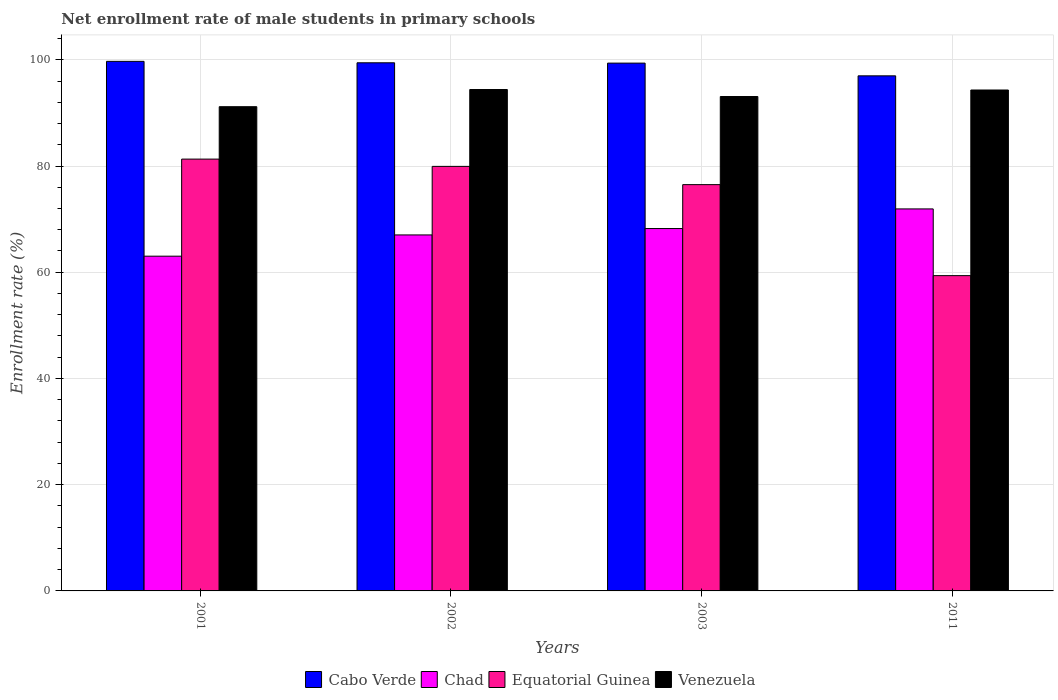How many groups of bars are there?
Give a very brief answer. 4. Are the number of bars per tick equal to the number of legend labels?
Keep it short and to the point. Yes. Are the number of bars on each tick of the X-axis equal?
Provide a succinct answer. Yes. What is the label of the 2nd group of bars from the left?
Your response must be concise. 2002. What is the net enrollment rate of male students in primary schools in Cabo Verde in 2011?
Make the answer very short. 96.98. Across all years, what is the maximum net enrollment rate of male students in primary schools in Chad?
Provide a succinct answer. 71.92. Across all years, what is the minimum net enrollment rate of male students in primary schools in Chad?
Provide a short and direct response. 63.02. In which year was the net enrollment rate of male students in primary schools in Cabo Verde maximum?
Keep it short and to the point. 2001. What is the total net enrollment rate of male students in primary schools in Cabo Verde in the graph?
Provide a succinct answer. 395.49. What is the difference between the net enrollment rate of male students in primary schools in Venezuela in 2003 and that in 2011?
Ensure brevity in your answer.  -1.23. What is the difference between the net enrollment rate of male students in primary schools in Cabo Verde in 2001 and the net enrollment rate of male students in primary schools in Chad in 2002?
Your response must be concise. 32.68. What is the average net enrollment rate of male students in primary schools in Chad per year?
Provide a succinct answer. 67.55. In the year 2003, what is the difference between the net enrollment rate of male students in primary schools in Equatorial Guinea and net enrollment rate of male students in primary schools in Chad?
Keep it short and to the point. 8.27. What is the ratio of the net enrollment rate of male students in primary schools in Chad in 2001 to that in 2003?
Offer a terse response. 0.92. Is the difference between the net enrollment rate of male students in primary schools in Equatorial Guinea in 2002 and 2011 greater than the difference between the net enrollment rate of male students in primary schools in Chad in 2002 and 2011?
Provide a succinct answer. Yes. What is the difference between the highest and the second highest net enrollment rate of male students in primary schools in Equatorial Guinea?
Offer a very short reply. 1.37. What is the difference between the highest and the lowest net enrollment rate of male students in primary schools in Equatorial Guinea?
Make the answer very short. 21.94. Is it the case that in every year, the sum of the net enrollment rate of male students in primary schools in Cabo Verde and net enrollment rate of male students in primary schools in Equatorial Guinea is greater than the sum of net enrollment rate of male students in primary schools in Chad and net enrollment rate of male students in primary schools in Venezuela?
Keep it short and to the point. Yes. What does the 2nd bar from the left in 2002 represents?
Your response must be concise. Chad. What does the 2nd bar from the right in 2001 represents?
Provide a succinct answer. Equatorial Guinea. Is it the case that in every year, the sum of the net enrollment rate of male students in primary schools in Equatorial Guinea and net enrollment rate of male students in primary schools in Cabo Verde is greater than the net enrollment rate of male students in primary schools in Chad?
Give a very brief answer. Yes. Are all the bars in the graph horizontal?
Your answer should be very brief. No. How many years are there in the graph?
Your answer should be compact. 4. Does the graph contain any zero values?
Ensure brevity in your answer.  No. How are the legend labels stacked?
Provide a short and direct response. Horizontal. What is the title of the graph?
Provide a succinct answer. Net enrollment rate of male students in primary schools. What is the label or title of the X-axis?
Ensure brevity in your answer.  Years. What is the label or title of the Y-axis?
Your answer should be compact. Enrollment rate (%). What is the Enrollment rate (%) of Cabo Verde in 2001?
Your response must be concise. 99.71. What is the Enrollment rate (%) of Chad in 2001?
Offer a very short reply. 63.02. What is the Enrollment rate (%) of Equatorial Guinea in 2001?
Keep it short and to the point. 81.3. What is the Enrollment rate (%) in Venezuela in 2001?
Provide a short and direct response. 91.17. What is the Enrollment rate (%) of Cabo Verde in 2002?
Keep it short and to the point. 99.43. What is the Enrollment rate (%) in Chad in 2002?
Your answer should be very brief. 67.02. What is the Enrollment rate (%) of Equatorial Guinea in 2002?
Give a very brief answer. 79.93. What is the Enrollment rate (%) of Venezuela in 2002?
Provide a succinct answer. 94.4. What is the Enrollment rate (%) in Cabo Verde in 2003?
Ensure brevity in your answer.  99.38. What is the Enrollment rate (%) in Chad in 2003?
Your response must be concise. 68.23. What is the Enrollment rate (%) of Equatorial Guinea in 2003?
Make the answer very short. 76.5. What is the Enrollment rate (%) of Venezuela in 2003?
Make the answer very short. 93.08. What is the Enrollment rate (%) in Cabo Verde in 2011?
Provide a short and direct response. 96.98. What is the Enrollment rate (%) of Chad in 2011?
Offer a very short reply. 71.92. What is the Enrollment rate (%) of Equatorial Guinea in 2011?
Your answer should be compact. 59.36. What is the Enrollment rate (%) of Venezuela in 2011?
Your response must be concise. 94.31. Across all years, what is the maximum Enrollment rate (%) of Cabo Verde?
Your answer should be compact. 99.71. Across all years, what is the maximum Enrollment rate (%) of Chad?
Your answer should be compact. 71.92. Across all years, what is the maximum Enrollment rate (%) in Equatorial Guinea?
Offer a very short reply. 81.3. Across all years, what is the maximum Enrollment rate (%) of Venezuela?
Provide a succinct answer. 94.4. Across all years, what is the minimum Enrollment rate (%) of Cabo Verde?
Your response must be concise. 96.98. Across all years, what is the minimum Enrollment rate (%) of Chad?
Offer a very short reply. 63.02. Across all years, what is the minimum Enrollment rate (%) in Equatorial Guinea?
Make the answer very short. 59.36. Across all years, what is the minimum Enrollment rate (%) in Venezuela?
Provide a succinct answer. 91.17. What is the total Enrollment rate (%) of Cabo Verde in the graph?
Provide a succinct answer. 395.49. What is the total Enrollment rate (%) of Chad in the graph?
Your response must be concise. 270.2. What is the total Enrollment rate (%) of Equatorial Guinea in the graph?
Your response must be concise. 297.09. What is the total Enrollment rate (%) in Venezuela in the graph?
Your response must be concise. 372.97. What is the difference between the Enrollment rate (%) of Cabo Verde in 2001 and that in 2002?
Your answer should be very brief. 0.27. What is the difference between the Enrollment rate (%) in Chad in 2001 and that in 2002?
Offer a very short reply. -4. What is the difference between the Enrollment rate (%) in Equatorial Guinea in 2001 and that in 2002?
Provide a short and direct response. 1.37. What is the difference between the Enrollment rate (%) in Venezuela in 2001 and that in 2002?
Give a very brief answer. -3.23. What is the difference between the Enrollment rate (%) in Cabo Verde in 2001 and that in 2003?
Keep it short and to the point. 0.33. What is the difference between the Enrollment rate (%) in Chad in 2001 and that in 2003?
Keep it short and to the point. -5.21. What is the difference between the Enrollment rate (%) of Equatorial Guinea in 2001 and that in 2003?
Offer a terse response. 4.8. What is the difference between the Enrollment rate (%) of Venezuela in 2001 and that in 2003?
Offer a terse response. -1.91. What is the difference between the Enrollment rate (%) in Cabo Verde in 2001 and that in 2011?
Make the answer very short. 2.73. What is the difference between the Enrollment rate (%) in Chad in 2001 and that in 2011?
Ensure brevity in your answer.  -8.9. What is the difference between the Enrollment rate (%) of Equatorial Guinea in 2001 and that in 2011?
Your answer should be very brief. 21.94. What is the difference between the Enrollment rate (%) of Venezuela in 2001 and that in 2011?
Offer a terse response. -3.14. What is the difference between the Enrollment rate (%) of Cabo Verde in 2002 and that in 2003?
Provide a short and direct response. 0.06. What is the difference between the Enrollment rate (%) in Chad in 2002 and that in 2003?
Your answer should be very brief. -1.2. What is the difference between the Enrollment rate (%) of Equatorial Guinea in 2002 and that in 2003?
Provide a succinct answer. 3.44. What is the difference between the Enrollment rate (%) in Venezuela in 2002 and that in 2003?
Ensure brevity in your answer.  1.32. What is the difference between the Enrollment rate (%) in Cabo Verde in 2002 and that in 2011?
Make the answer very short. 2.46. What is the difference between the Enrollment rate (%) of Chad in 2002 and that in 2011?
Provide a short and direct response. -4.9. What is the difference between the Enrollment rate (%) of Equatorial Guinea in 2002 and that in 2011?
Your answer should be compact. 20.57. What is the difference between the Enrollment rate (%) in Venezuela in 2002 and that in 2011?
Give a very brief answer. 0.09. What is the difference between the Enrollment rate (%) in Cabo Verde in 2003 and that in 2011?
Provide a short and direct response. 2.4. What is the difference between the Enrollment rate (%) in Chad in 2003 and that in 2011?
Give a very brief answer. -3.69. What is the difference between the Enrollment rate (%) of Equatorial Guinea in 2003 and that in 2011?
Keep it short and to the point. 17.14. What is the difference between the Enrollment rate (%) of Venezuela in 2003 and that in 2011?
Keep it short and to the point. -1.23. What is the difference between the Enrollment rate (%) of Cabo Verde in 2001 and the Enrollment rate (%) of Chad in 2002?
Your answer should be compact. 32.68. What is the difference between the Enrollment rate (%) in Cabo Verde in 2001 and the Enrollment rate (%) in Equatorial Guinea in 2002?
Your answer should be very brief. 19.77. What is the difference between the Enrollment rate (%) of Cabo Verde in 2001 and the Enrollment rate (%) of Venezuela in 2002?
Offer a terse response. 5.31. What is the difference between the Enrollment rate (%) of Chad in 2001 and the Enrollment rate (%) of Equatorial Guinea in 2002?
Ensure brevity in your answer.  -16.91. What is the difference between the Enrollment rate (%) in Chad in 2001 and the Enrollment rate (%) in Venezuela in 2002?
Provide a short and direct response. -31.38. What is the difference between the Enrollment rate (%) in Equatorial Guinea in 2001 and the Enrollment rate (%) in Venezuela in 2002?
Provide a short and direct response. -13.1. What is the difference between the Enrollment rate (%) in Cabo Verde in 2001 and the Enrollment rate (%) in Chad in 2003?
Make the answer very short. 31.48. What is the difference between the Enrollment rate (%) of Cabo Verde in 2001 and the Enrollment rate (%) of Equatorial Guinea in 2003?
Ensure brevity in your answer.  23.21. What is the difference between the Enrollment rate (%) in Cabo Verde in 2001 and the Enrollment rate (%) in Venezuela in 2003?
Your answer should be very brief. 6.62. What is the difference between the Enrollment rate (%) in Chad in 2001 and the Enrollment rate (%) in Equatorial Guinea in 2003?
Your response must be concise. -13.47. What is the difference between the Enrollment rate (%) of Chad in 2001 and the Enrollment rate (%) of Venezuela in 2003?
Ensure brevity in your answer.  -30.06. What is the difference between the Enrollment rate (%) of Equatorial Guinea in 2001 and the Enrollment rate (%) of Venezuela in 2003?
Your answer should be very brief. -11.78. What is the difference between the Enrollment rate (%) of Cabo Verde in 2001 and the Enrollment rate (%) of Chad in 2011?
Offer a very short reply. 27.78. What is the difference between the Enrollment rate (%) of Cabo Verde in 2001 and the Enrollment rate (%) of Equatorial Guinea in 2011?
Provide a succinct answer. 40.35. What is the difference between the Enrollment rate (%) in Cabo Verde in 2001 and the Enrollment rate (%) in Venezuela in 2011?
Ensure brevity in your answer.  5.39. What is the difference between the Enrollment rate (%) in Chad in 2001 and the Enrollment rate (%) in Equatorial Guinea in 2011?
Provide a succinct answer. 3.66. What is the difference between the Enrollment rate (%) of Chad in 2001 and the Enrollment rate (%) of Venezuela in 2011?
Provide a succinct answer. -31.29. What is the difference between the Enrollment rate (%) in Equatorial Guinea in 2001 and the Enrollment rate (%) in Venezuela in 2011?
Your answer should be compact. -13.01. What is the difference between the Enrollment rate (%) of Cabo Verde in 2002 and the Enrollment rate (%) of Chad in 2003?
Your response must be concise. 31.21. What is the difference between the Enrollment rate (%) of Cabo Verde in 2002 and the Enrollment rate (%) of Equatorial Guinea in 2003?
Ensure brevity in your answer.  22.94. What is the difference between the Enrollment rate (%) in Cabo Verde in 2002 and the Enrollment rate (%) in Venezuela in 2003?
Keep it short and to the point. 6.35. What is the difference between the Enrollment rate (%) of Chad in 2002 and the Enrollment rate (%) of Equatorial Guinea in 2003?
Your answer should be very brief. -9.47. What is the difference between the Enrollment rate (%) in Chad in 2002 and the Enrollment rate (%) in Venezuela in 2003?
Your answer should be very brief. -26.06. What is the difference between the Enrollment rate (%) of Equatorial Guinea in 2002 and the Enrollment rate (%) of Venezuela in 2003?
Offer a terse response. -13.15. What is the difference between the Enrollment rate (%) of Cabo Verde in 2002 and the Enrollment rate (%) of Chad in 2011?
Ensure brevity in your answer.  27.51. What is the difference between the Enrollment rate (%) of Cabo Verde in 2002 and the Enrollment rate (%) of Equatorial Guinea in 2011?
Your answer should be very brief. 40.07. What is the difference between the Enrollment rate (%) of Cabo Verde in 2002 and the Enrollment rate (%) of Venezuela in 2011?
Ensure brevity in your answer.  5.12. What is the difference between the Enrollment rate (%) of Chad in 2002 and the Enrollment rate (%) of Equatorial Guinea in 2011?
Your answer should be very brief. 7.66. What is the difference between the Enrollment rate (%) in Chad in 2002 and the Enrollment rate (%) in Venezuela in 2011?
Provide a succinct answer. -27.29. What is the difference between the Enrollment rate (%) of Equatorial Guinea in 2002 and the Enrollment rate (%) of Venezuela in 2011?
Make the answer very short. -14.38. What is the difference between the Enrollment rate (%) in Cabo Verde in 2003 and the Enrollment rate (%) in Chad in 2011?
Your answer should be compact. 27.45. What is the difference between the Enrollment rate (%) of Cabo Verde in 2003 and the Enrollment rate (%) of Equatorial Guinea in 2011?
Your answer should be compact. 40.01. What is the difference between the Enrollment rate (%) in Cabo Verde in 2003 and the Enrollment rate (%) in Venezuela in 2011?
Give a very brief answer. 5.06. What is the difference between the Enrollment rate (%) in Chad in 2003 and the Enrollment rate (%) in Equatorial Guinea in 2011?
Offer a terse response. 8.87. What is the difference between the Enrollment rate (%) of Chad in 2003 and the Enrollment rate (%) of Venezuela in 2011?
Ensure brevity in your answer.  -26.08. What is the difference between the Enrollment rate (%) in Equatorial Guinea in 2003 and the Enrollment rate (%) in Venezuela in 2011?
Keep it short and to the point. -17.82. What is the average Enrollment rate (%) of Cabo Verde per year?
Provide a succinct answer. 98.87. What is the average Enrollment rate (%) of Chad per year?
Keep it short and to the point. 67.55. What is the average Enrollment rate (%) of Equatorial Guinea per year?
Ensure brevity in your answer.  74.27. What is the average Enrollment rate (%) in Venezuela per year?
Offer a terse response. 93.24. In the year 2001, what is the difference between the Enrollment rate (%) in Cabo Verde and Enrollment rate (%) in Chad?
Your answer should be compact. 36.68. In the year 2001, what is the difference between the Enrollment rate (%) of Cabo Verde and Enrollment rate (%) of Equatorial Guinea?
Provide a short and direct response. 18.41. In the year 2001, what is the difference between the Enrollment rate (%) in Cabo Verde and Enrollment rate (%) in Venezuela?
Offer a very short reply. 8.54. In the year 2001, what is the difference between the Enrollment rate (%) of Chad and Enrollment rate (%) of Equatorial Guinea?
Your answer should be very brief. -18.28. In the year 2001, what is the difference between the Enrollment rate (%) in Chad and Enrollment rate (%) in Venezuela?
Your response must be concise. -28.14. In the year 2001, what is the difference between the Enrollment rate (%) in Equatorial Guinea and Enrollment rate (%) in Venezuela?
Provide a short and direct response. -9.87. In the year 2002, what is the difference between the Enrollment rate (%) in Cabo Verde and Enrollment rate (%) in Chad?
Your response must be concise. 32.41. In the year 2002, what is the difference between the Enrollment rate (%) of Cabo Verde and Enrollment rate (%) of Equatorial Guinea?
Provide a succinct answer. 19.5. In the year 2002, what is the difference between the Enrollment rate (%) of Cabo Verde and Enrollment rate (%) of Venezuela?
Offer a terse response. 5.03. In the year 2002, what is the difference between the Enrollment rate (%) in Chad and Enrollment rate (%) in Equatorial Guinea?
Offer a terse response. -12.91. In the year 2002, what is the difference between the Enrollment rate (%) of Chad and Enrollment rate (%) of Venezuela?
Ensure brevity in your answer.  -27.38. In the year 2002, what is the difference between the Enrollment rate (%) in Equatorial Guinea and Enrollment rate (%) in Venezuela?
Your answer should be very brief. -14.47. In the year 2003, what is the difference between the Enrollment rate (%) in Cabo Verde and Enrollment rate (%) in Chad?
Offer a very short reply. 31.15. In the year 2003, what is the difference between the Enrollment rate (%) in Cabo Verde and Enrollment rate (%) in Equatorial Guinea?
Your answer should be compact. 22.88. In the year 2003, what is the difference between the Enrollment rate (%) of Cabo Verde and Enrollment rate (%) of Venezuela?
Give a very brief answer. 6.29. In the year 2003, what is the difference between the Enrollment rate (%) in Chad and Enrollment rate (%) in Equatorial Guinea?
Provide a succinct answer. -8.27. In the year 2003, what is the difference between the Enrollment rate (%) of Chad and Enrollment rate (%) of Venezuela?
Offer a terse response. -24.85. In the year 2003, what is the difference between the Enrollment rate (%) of Equatorial Guinea and Enrollment rate (%) of Venezuela?
Provide a short and direct response. -16.59. In the year 2011, what is the difference between the Enrollment rate (%) in Cabo Verde and Enrollment rate (%) in Chad?
Give a very brief answer. 25.05. In the year 2011, what is the difference between the Enrollment rate (%) of Cabo Verde and Enrollment rate (%) of Equatorial Guinea?
Ensure brevity in your answer.  37.62. In the year 2011, what is the difference between the Enrollment rate (%) in Cabo Verde and Enrollment rate (%) in Venezuela?
Keep it short and to the point. 2.67. In the year 2011, what is the difference between the Enrollment rate (%) in Chad and Enrollment rate (%) in Equatorial Guinea?
Offer a very short reply. 12.56. In the year 2011, what is the difference between the Enrollment rate (%) in Chad and Enrollment rate (%) in Venezuela?
Give a very brief answer. -22.39. In the year 2011, what is the difference between the Enrollment rate (%) of Equatorial Guinea and Enrollment rate (%) of Venezuela?
Offer a very short reply. -34.95. What is the ratio of the Enrollment rate (%) of Chad in 2001 to that in 2002?
Your answer should be very brief. 0.94. What is the ratio of the Enrollment rate (%) of Equatorial Guinea in 2001 to that in 2002?
Provide a short and direct response. 1.02. What is the ratio of the Enrollment rate (%) of Venezuela in 2001 to that in 2002?
Provide a short and direct response. 0.97. What is the ratio of the Enrollment rate (%) of Chad in 2001 to that in 2003?
Ensure brevity in your answer.  0.92. What is the ratio of the Enrollment rate (%) in Equatorial Guinea in 2001 to that in 2003?
Keep it short and to the point. 1.06. What is the ratio of the Enrollment rate (%) in Venezuela in 2001 to that in 2003?
Ensure brevity in your answer.  0.98. What is the ratio of the Enrollment rate (%) of Cabo Verde in 2001 to that in 2011?
Your answer should be very brief. 1.03. What is the ratio of the Enrollment rate (%) in Chad in 2001 to that in 2011?
Keep it short and to the point. 0.88. What is the ratio of the Enrollment rate (%) of Equatorial Guinea in 2001 to that in 2011?
Ensure brevity in your answer.  1.37. What is the ratio of the Enrollment rate (%) in Venezuela in 2001 to that in 2011?
Your answer should be compact. 0.97. What is the ratio of the Enrollment rate (%) of Cabo Verde in 2002 to that in 2003?
Make the answer very short. 1. What is the ratio of the Enrollment rate (%) of Chad in 2002 to that in 2003?
Provide a short and direct response. 0.98. What is the ratio of the Enrollment rate (%) in Equatorial Guinea in 2002 to that in 2003?
Your answer should be compact. 1.04. What is the ratio of the Enrollment rate (%) of Venezuela in 2002 to that in 2003?
Offer a very short reply. 1.01. What is the ratio of the Enrollment rate (%) in Cabo Verde in 2002 to that in 2011?
Provide a short and direct response. 1.03. What is the ratio of the Enrollment rate (%) of Chad in 2002 to that in 2011?
Keep it short and to the point. 0.93. What is the ratio of the Enrollment rate (%) of Equatorial Guinea in 2002 to that in 2011?
Make the answer very short. 1.35. What is the ratio of the Enrollment rate (%) in Cabo Verde in 2003 to that in 2011?
Give a very brief answer. 1.02. What is the ratio of the Enrollment rate (%) in Chad in 2003 to that in 2011?
Your answer should be very brief. 0.95. What is the ratio of the Enrollment rate (%) of Equatorial Guinea in 2003 to that in 2011?
Your answer should be very brief. 1.29. What is the difference between the highest and the second highest Enrollment rate (%) of Cabo Verde?
Give a very brief answer. 0.27. What is the difference between the highest and the second highest Enrollment rate (%) in Chad?
Ensure brevity in your answer.  3.69. What is the difference between the highest and the second highest Enrollment rate (%) of Equatorial Guinea?
Offer a very short reply. 1.37. What is the difference between the highest and the second highest Enrollment rate (%) of Venezuela?
Provide a succinct answer. 0.09. What is the difference between the highest and the lowest Enrollment rate (%) of Cabo Verde?
Keep it short and to the point. 2.73. What is the difference between the highest and the lowest Enrollment rate (%) of Chad?
Offer a very short reply. 8.9. What is the difference between the highest and the lowest Enrollment rate (%) in Equatorial Guinea?
Your answer should be very brief. 21.94. What is the difference between the highest and the lowest Enrollment rate (%) of Venezuela?
Provide a short and direct response. 3.23. 